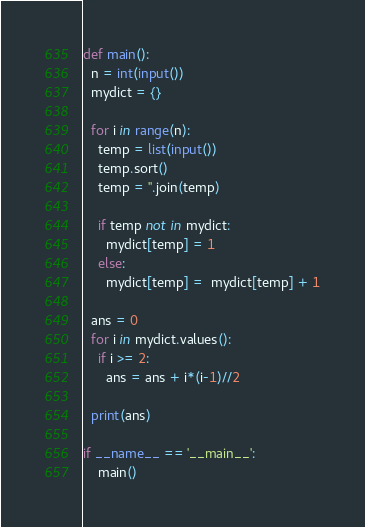<code> <loc_0><loc_0><loc_500><loc_500><_Python_>def main():
  n = int(input())
  mydict = {}

  for i in range(n):
    temp = list(input())
    temp.sort()
    temp = ''.join(temp)
    
    if temp not in mydict:
      mydict[temp] = 1
    else:
      mydict[temp] =  mydict[temp] + 1
      
  ans = 0
  for i in mydict.values():
    if i >= 2:
      ans = ans + i*(i-1)//2
    
  print(ans)
  
if __name__ == '__main__':
    main()</code> 